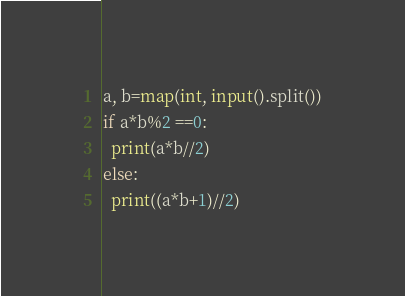<code> <loc_0><loc_0><loc_500><loc_500><_Python_>a, b=map(int, input().split())
if a*b%2 ==0:
  print(a*b//2)
else:
  print((a*b+1)//2)  </code> 